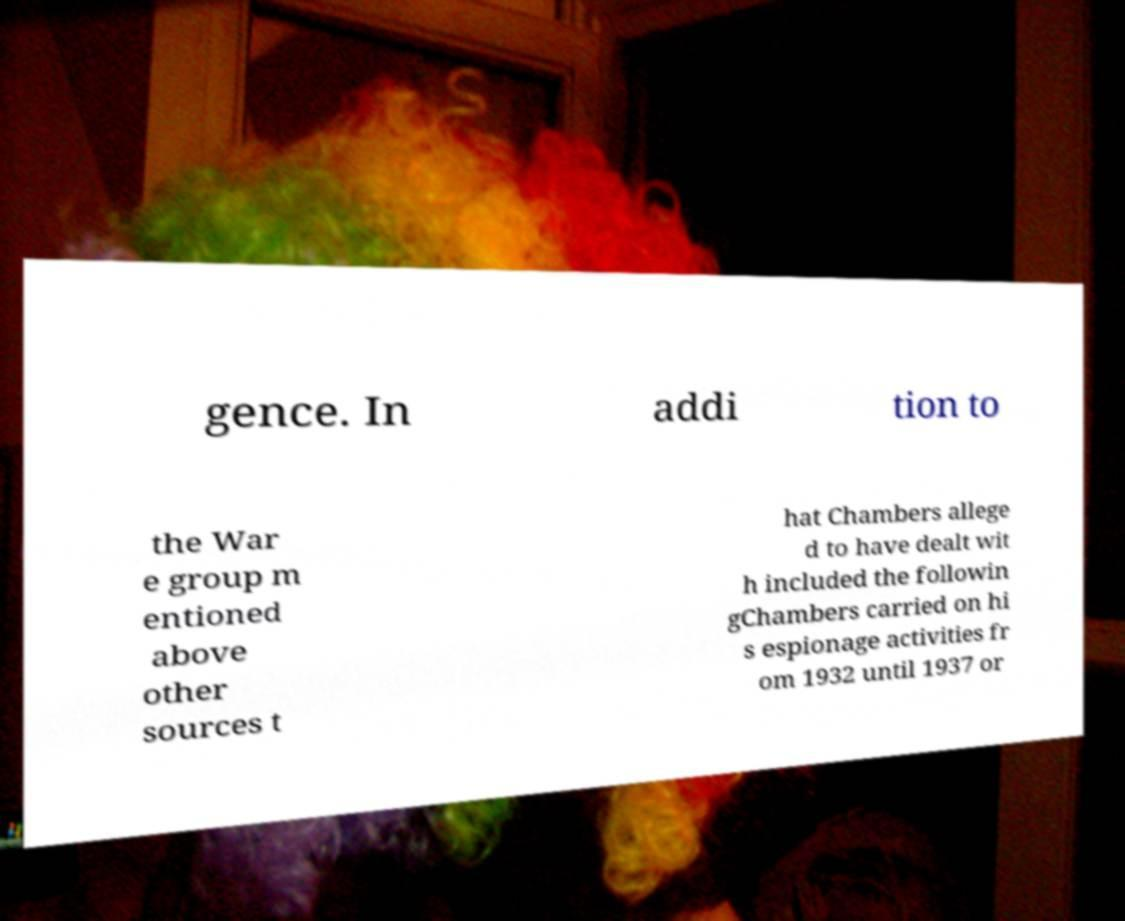For documentation purposes, I need the text within this image transcribed. Could you provide that? gence. In addi tion to the War e group m entioned above other sources t hat Chambers allege d to have dealt wit h included the followin gChambers carried on hi s espionage activities fr om 1932 until 1937 or 